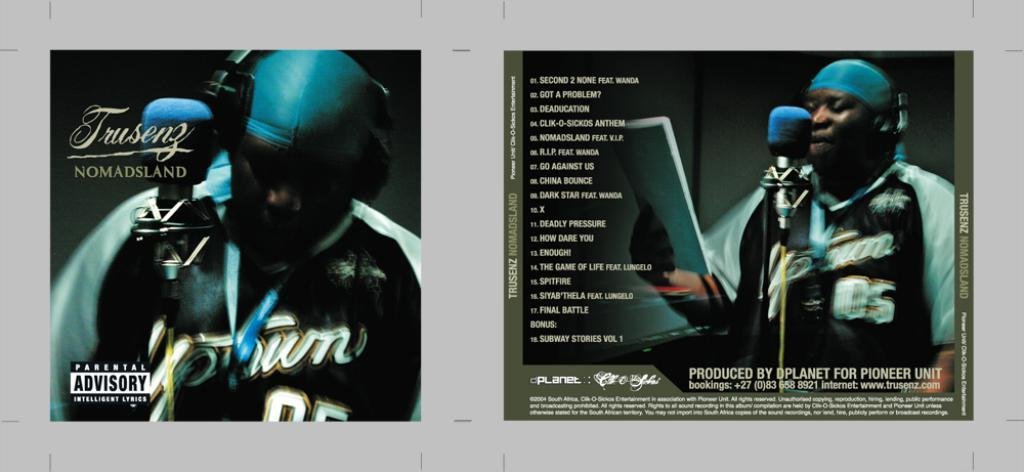<image>
Relay a brief, clear account of the picture shown. An album with the title of Nomadsland is shown in it's entirety. 